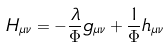Convert formula to latex. <formula><loc_0><loc_0><loc_500><loc_500>H _ { \mu \nu } = - \frac { \lambda } { \Phi } g _ { \mu \nu } + \frac { 1 } { \Phi } h _ { \mu \nu }</formula> 